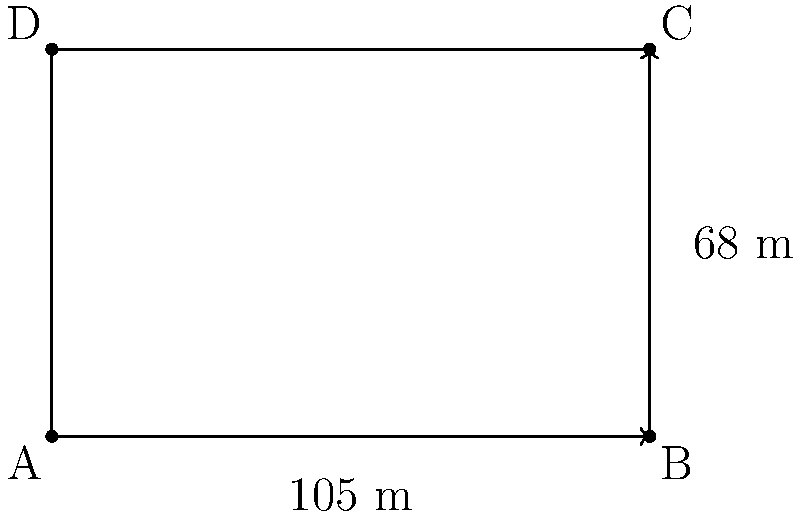Hola, companys! As a cartoonist, I'm sketching a scene at the Camp Nou. The football pitch measures 105 meters in length and 68 meters in width. What's the total area of this magnificent playing field where our heroes showcase their skills? Let's break this down, amigos:

1) The football pitch is a rectangle. To find its area, we multiply its length by its width.

2) We're given:
   Length = 105 meters
   Width = 68 meters

3) The formula for the area of a rectangle is:
   $$ A = l \times w $$
   Where $A$ is the area, $l$ is the length, and $w$ is the width.

4) Let's substitute our values:
   $$ A = 105 \times 68 $$

5) Now, let's calculate:
   $$ A = 7,140 \text{ square meters} $$

So, the total area of the Camp Nou pitch is 7,140 square meters. That's a lot of space for our Barça stars to weave their magic!
Answer: 7,140 m² 